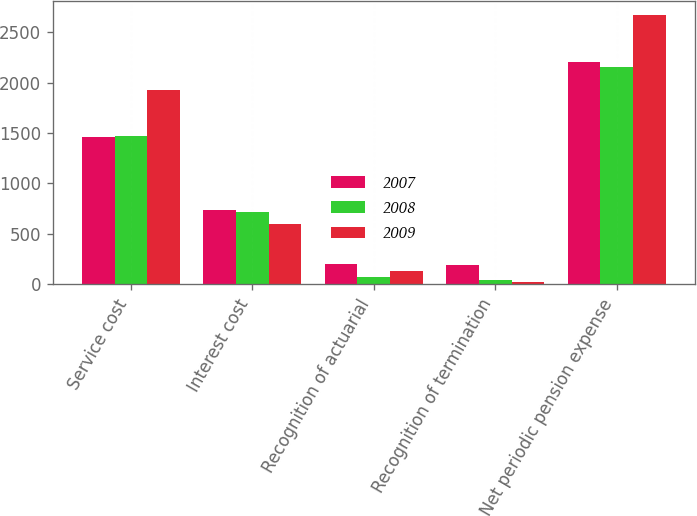<chart> <loc_0><loc_0><loc_500><loc_500><stacked_bar_chart><ecel><fcel>Service cost<fcel>Interest cost<fcel>Recognition of actuarial<fcel>Recognition of termination<fcel>Net periodic pension expense<nl><fcel>2007<fcel>1465<fcel>742<fcel>200<fcel>192<fcel>2199<nl><fcel>2008<fcel>1470<fcel>717<fcel>74<fcel>40<fcel>2153<nl><fcel>2009<fcel>1922<fcel>599<fcel>129<fcel>24<fcel>2674<nl></chart> 